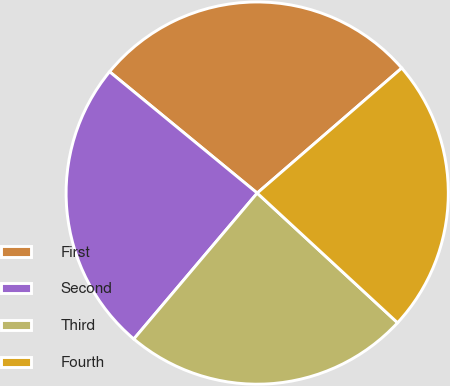<chart> <loc_0><loc_0><loc_500><loc_500><pie_chart><fcel>First<fcel>Second<fcel>Third<fcel>Fourth<nl><fcel>27.7%<fcel>24.78%<fcel>24.3%<fcel>23.22%<nl></chart> 